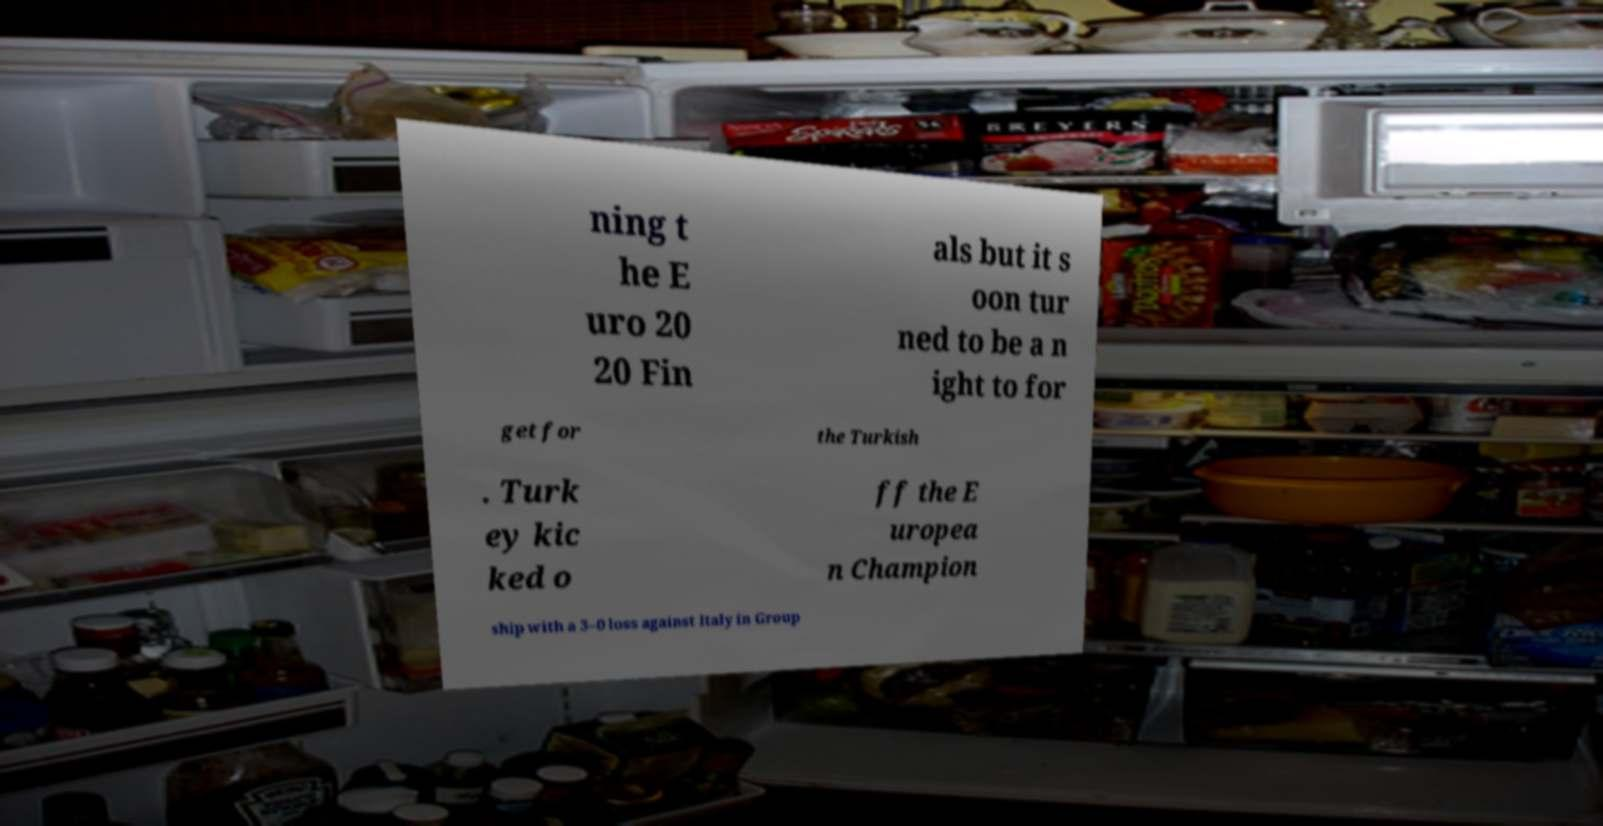There's text embedded in this image that I need extracted. Can you transcribe it verbatim? ning t he E uro 20 20 Fin als but it s oon tur ned to be a n ight to for get for the Turkish . Turk ey kic ked o ff the E uropea n Champion ship with a 3–0 loss against Italy in Group 